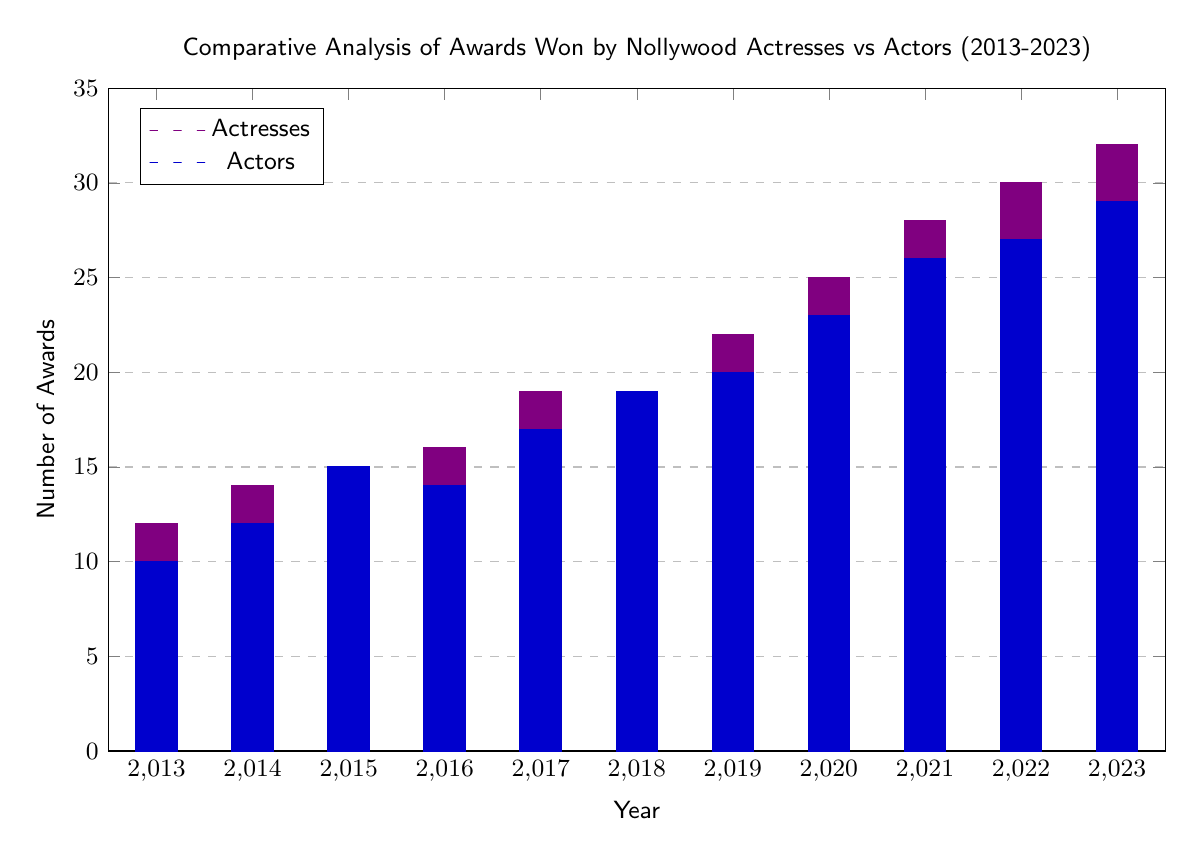What year did Nollywood actresses win the most awards? The data for actresses' awards peaks in 2023 with 32 awards, as indicated by the highest bar in the graph.
Answer: 32 What is the total number of awards won by actors in 2019? According to the bar for actors in 2019, the number is 20. This value is obtained directly from the graph's y-axis corresponding to the year 2019.
Answer: 20 Which group, actresses or actors, had more awards in 2017? In 2017, actresses won 19 awards while actors won 17 awards, making actresses the group with more awards that year.
Answer: Actresses What significant event in 2020 affected award nominations? The note in the diagram mentions that the COVID-19 pandemic reduced award events and nominations in 2020. This context provides clarity on the impact on awards during that year.
Answer: COVID-19 Pandemic How many awards did Nollywood actresses win in 2016? The graph shows that in 2016, actresses won 16 awards as indicated by the height of the corresponding bar for that year.
Answer: 16 What was the increase in awards won by actors from 2013 to 2023? The number of awards won by actors increased from 10 in 2013 to 29 in 2023. The difference can be calculated as 29 - 10 = 19.
Answer: 19 What is the trend of awards won by actresses from 2013 to 2023? By observing the bars, one can see a general upward trend in the number of awards won by actresses each year, indicating an overall increase in recognition over the decade.
Answer: Upward trend What year had the highest total awards for actors? From the data, 2023 shows the highest total for actors, which is 29 awards tracked by the highest bar for that year.
Answer: 29 Which actress won a notable award in 2016? The text note highlights that Genevieve Nnaji won the Africa Magic Viewers' Choice Award in 2016, indicating a significant milestone for that year.
Answer: Genevieve Nnaji 